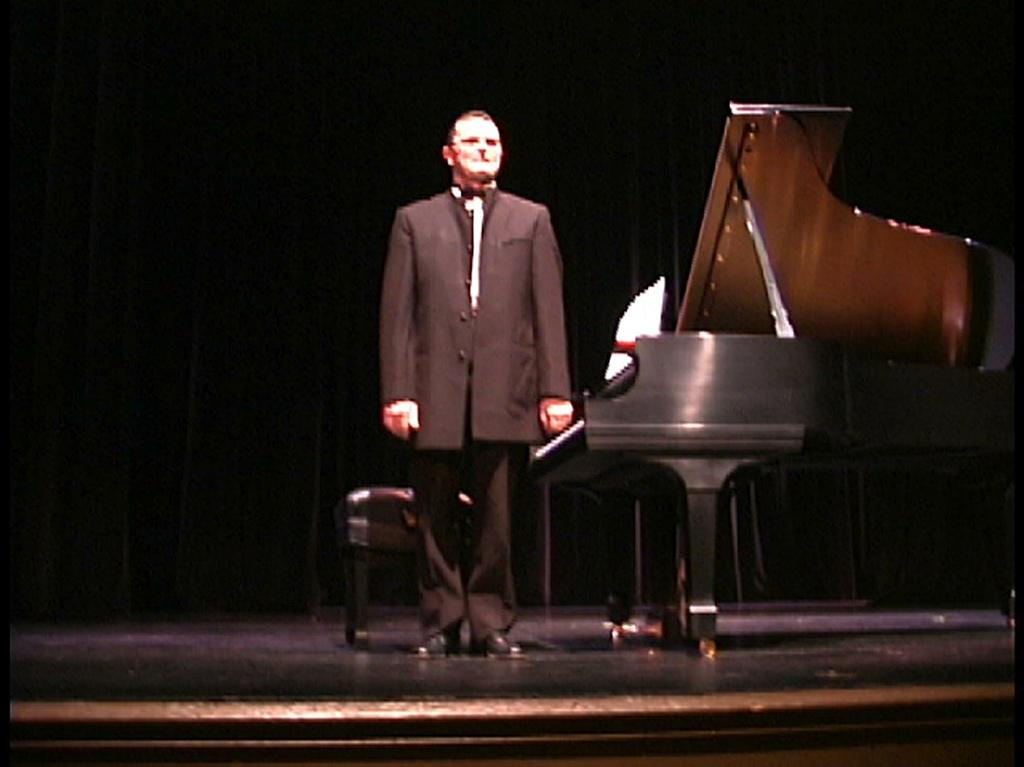What is the man doing in the image? The man is standing on stage in the image. What is located near the man on stage? The man is near a piano in the image. What can be seen in the background of the image? There is a curtain in the background of the image. What color is the curtain? The curtain is black in color. What is the man wearing? The man is wearing a blazer and black shoes. How many horses are visible on stage with the man in the image? There are no horses visible on stage with the man in the image. What is the name of the man standing on stage in the image? The provided facts do not include the name of the man. 